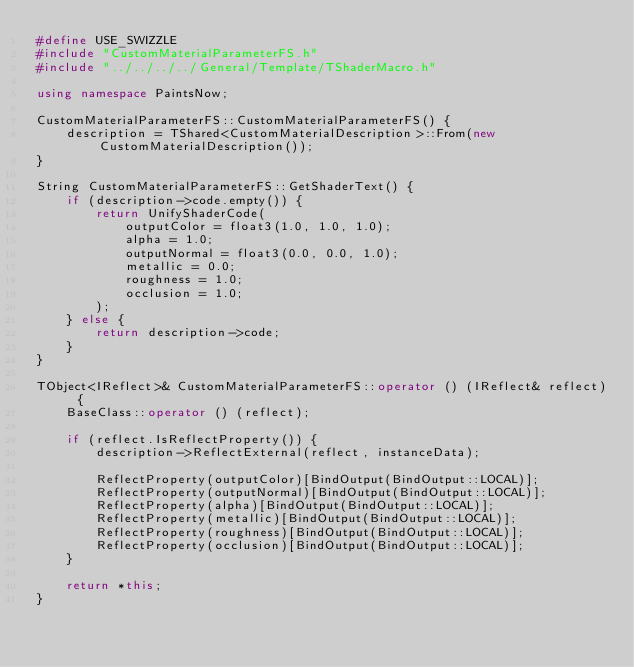<code> <loc_0><loc_0><loc_500><loc_500><_C++_>#define USE_SWIZZLE
#include "CustomMaterialParameterFS.h"
#include "../../../../General/Template/TShaderMacro.h"

using namespace PaintsNow;

CustomMaterialParameterFS::CustomMaterialParameterFS() {
	description = TShared<CustomMaterialDescription>::From(new CustomMaterialDescription());
}

String CustomMaterialParameterFS::GetShaderText() {
	if (description->code.empty()) {
		return UnifyShaderCode(
			outputColor = float3(1.0, 1.0, 1.0);
			alpha = 1.0;
			outputNormal = float3(0.0, 0.0, 1.0);
			metallic = 0.0;
			roughness = 1.0;
			occlusion = 1.0;
		);
	} else {
		return description->code;
	}
}

TObject<IReflect>& CustomMaterialParameterFS::operator () (IReflect& reflect) {
	BaseClass::operator () (reflect);

	if (reflect.IsReflectProperty()) {
		description->ReflectExternal(reflect, instanceData);

		ReflectProperty(outputColor)[BindOutput(BindOutput::LOCAL)];
		ReflectProperty(outputNormal)[BindOutput(BindOutput::LOCAL)];
		ReflectProperty(alpha)[BindOutput(BindOutput::LOCAL)];
		ReflectProperty(metallic)[BindOutput(BindOutput::LOCAL)];
		ReflectProperty(roughness)[BindOutput(BindOutput::LOCAL)];
		ReflectProperty(occlusion)[BindOutput(BindOutput::LOCAL)];
	}

	return *this;
}
</code> 